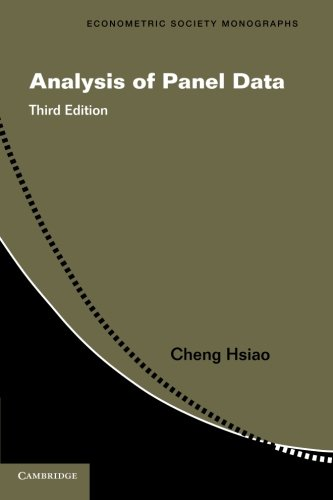What edition of this book is shown in the image, and what does it imply about its comprehensiveness over previous editions? The image shows the third edition of 'Analysis of Panel Data.' Each new edition typically includes updated research, expanded discussions on methodologies, and reflections on the latest advancements in the field. 